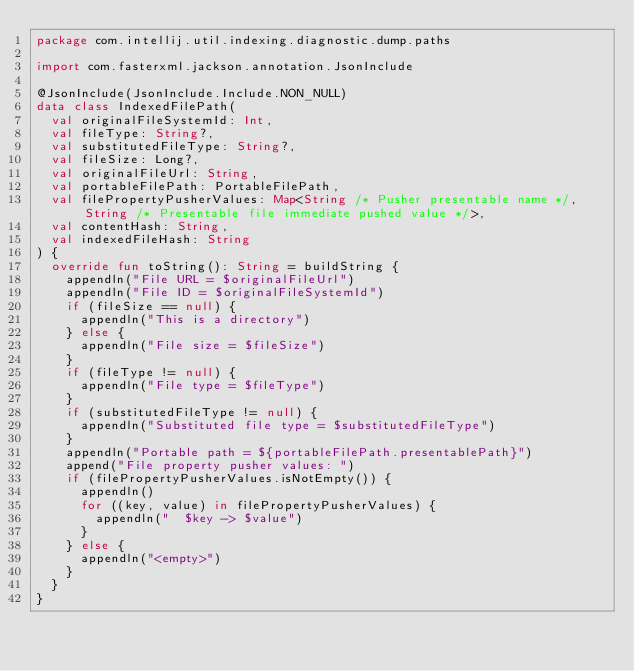<code> <loc_0><loc_0><loc_500><loc_500><_Kotlin_>package com.intellij.util.indexing.diagnostic.dump.paths

import com.fasterxml.jackson.annotation.JsonInclude

@JsonInclude(JsonInclude.Include.NON_NULL)
data class IndexedFilePath(
  val originalFileSystemId: Int,
  val fileType: String?,
  val substitutedFileType: String?,
  val fileSize: Long?,
  val originalFileUrl: String,
  val portableFilePath: PortableFilePath,
  val filePropertyPusherValues: Map<String /* Pusher presentable name */, String /* Presentable file immediate pushed value */>,
  val contentHash: String,
  val indexedFileHash: String
) {
  override fun toString(): String = buildString {
    appendln("File URL = $originalFileUrl")
    appendln("File ID = $originalFileSystemId")
    if (fileSize == null) {
      appendln("This is a directory")
    } else {
      appendln("File size = $fileSize")
    }
    if (fileType != null) {
      appendln("File type = $fileType")
    }
    if (substitutedFileType != null) {
      appendln("Substituted file type = $substitutedFileType")
    }
    appendln("Portable path = ${portableFilePath.presentablePath}")
    append("File property pusher values: ")
    if (filePropertyPusherValues.isNotEmpty()) {
      appendln()
      for ((key, value) in filePropertyPusherValues) {
        appendln("  $key -> $value")
      }
    } else {
      appendln("<empty>")
    }
  }
}</code> 